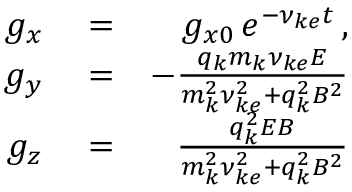<formula> <loc_0><loc_0><loc_500><loc_500>\begin{array} { r l r } { g _ { x } } & = } & { g _ { x 0 } \, e ^ { - \nu _ { k e } t } \, , } \\ { g _ { y } } & = } & { - \frac { q _ { k } m _ { k } \nu _ { k e } E } { m _ { k } ^ { 2 } \nu _ { k e } ^ { 2 } + q _ { k } ^ { 2 } B ^ { 2 } } } \\ { g _ { z } } & = } & { \frac { q _ { k } ^ { 2 } E B } { m _ { k } ^ { 2 } \nu _ { k e } ^ { 2 } + q _ { k } ^ { 2 } B ^ { 2 } } } \end{array}</formula> 